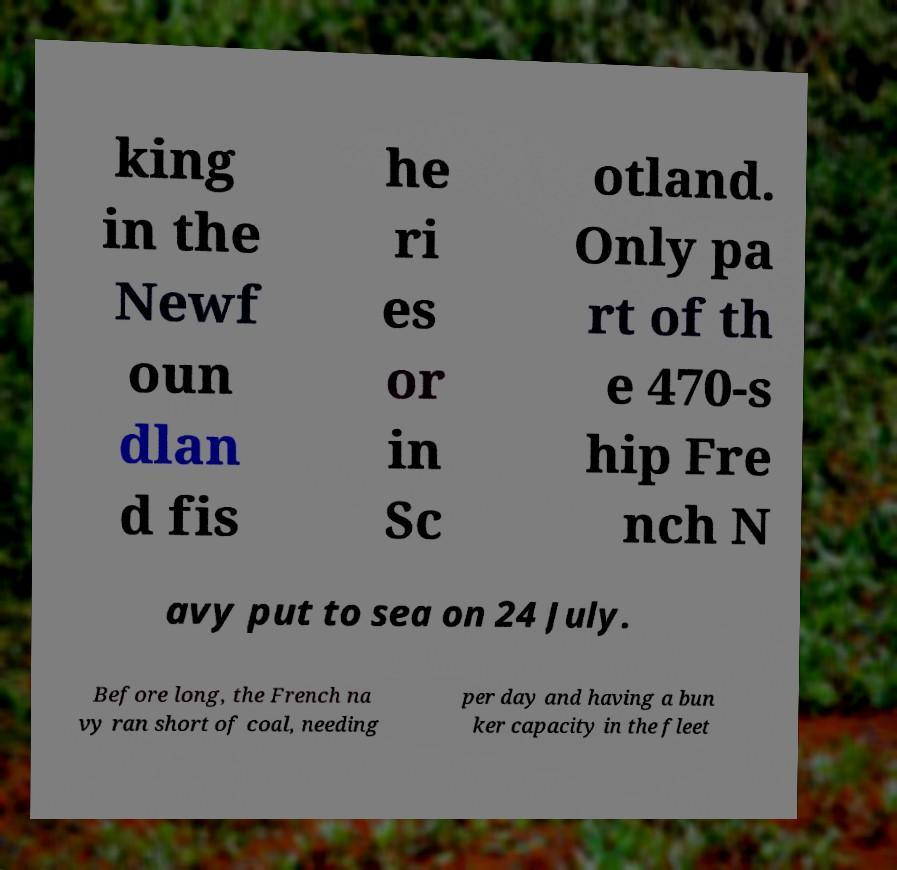Please identify and transcribe the text found in this image. king in the Newf oun dlan d fis he ri es or in Sc otland. Only pa rt of th e 470-s hip Fre nch N avy put to sea on 24 July. Before long, the French na vy ran short of coal, needing per day and having a bun ker capacity in the fleet 